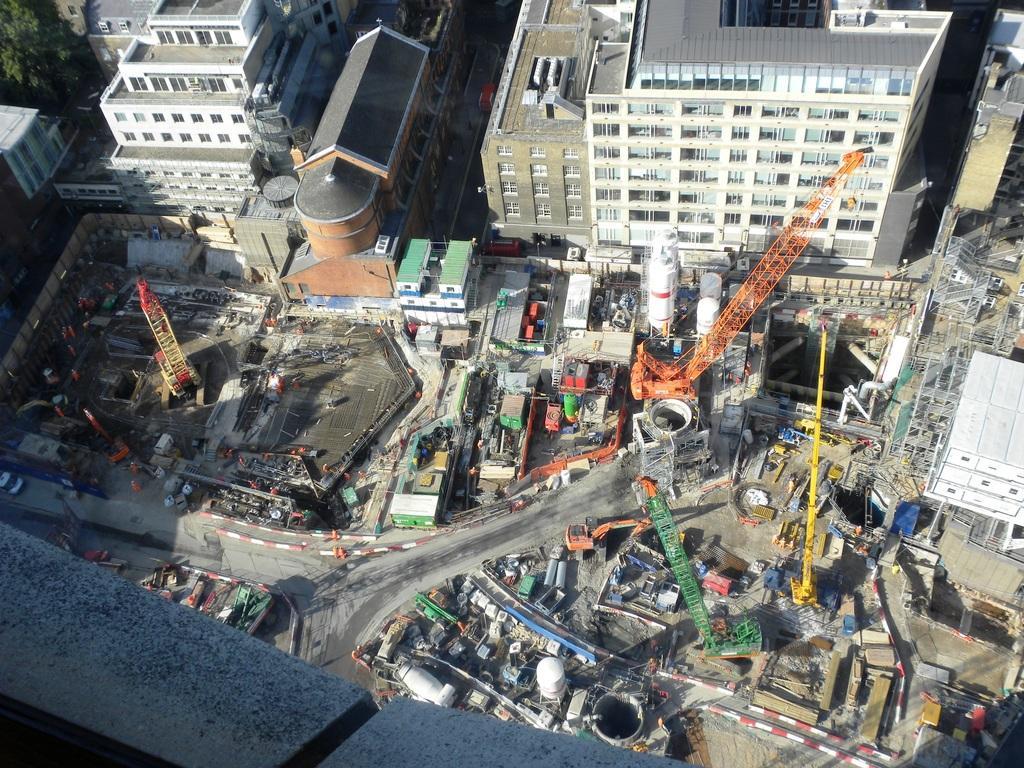Can you describe this image briefly? In this image we can see tree, buildings, windows and vehicles. 